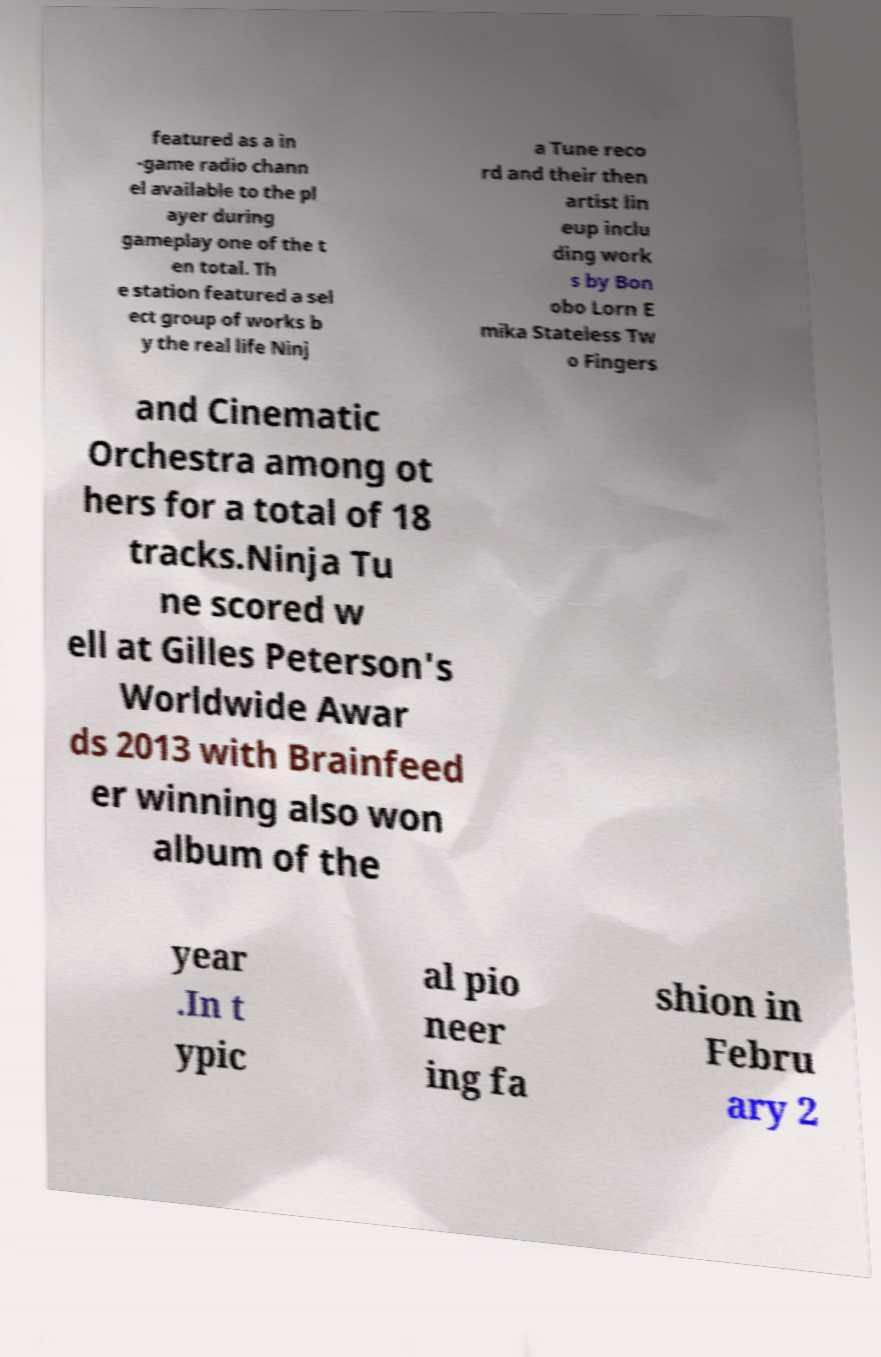Can you accurately transcribe the text from the provided image for me? featured as a in -game radio chann el available to the pl ayer during gameplay one of the t en total. Th e station featured a sel ect group of works b y the real life Ninj a Tune reco rd and their then artist lin eup inclu ding work s by Bon obo Lorn E mika Stateless Tw o Fingers and Cinematic Orchestra among ot hers for a total of 18 tracks.Ninja Tu ne scored w ell at Gilles Peterson's Worldwide Awar ds 2013 with Brainfeed er winning also won album of the year .In t ypic al pio neer ing fa shion in Febru ary 2 